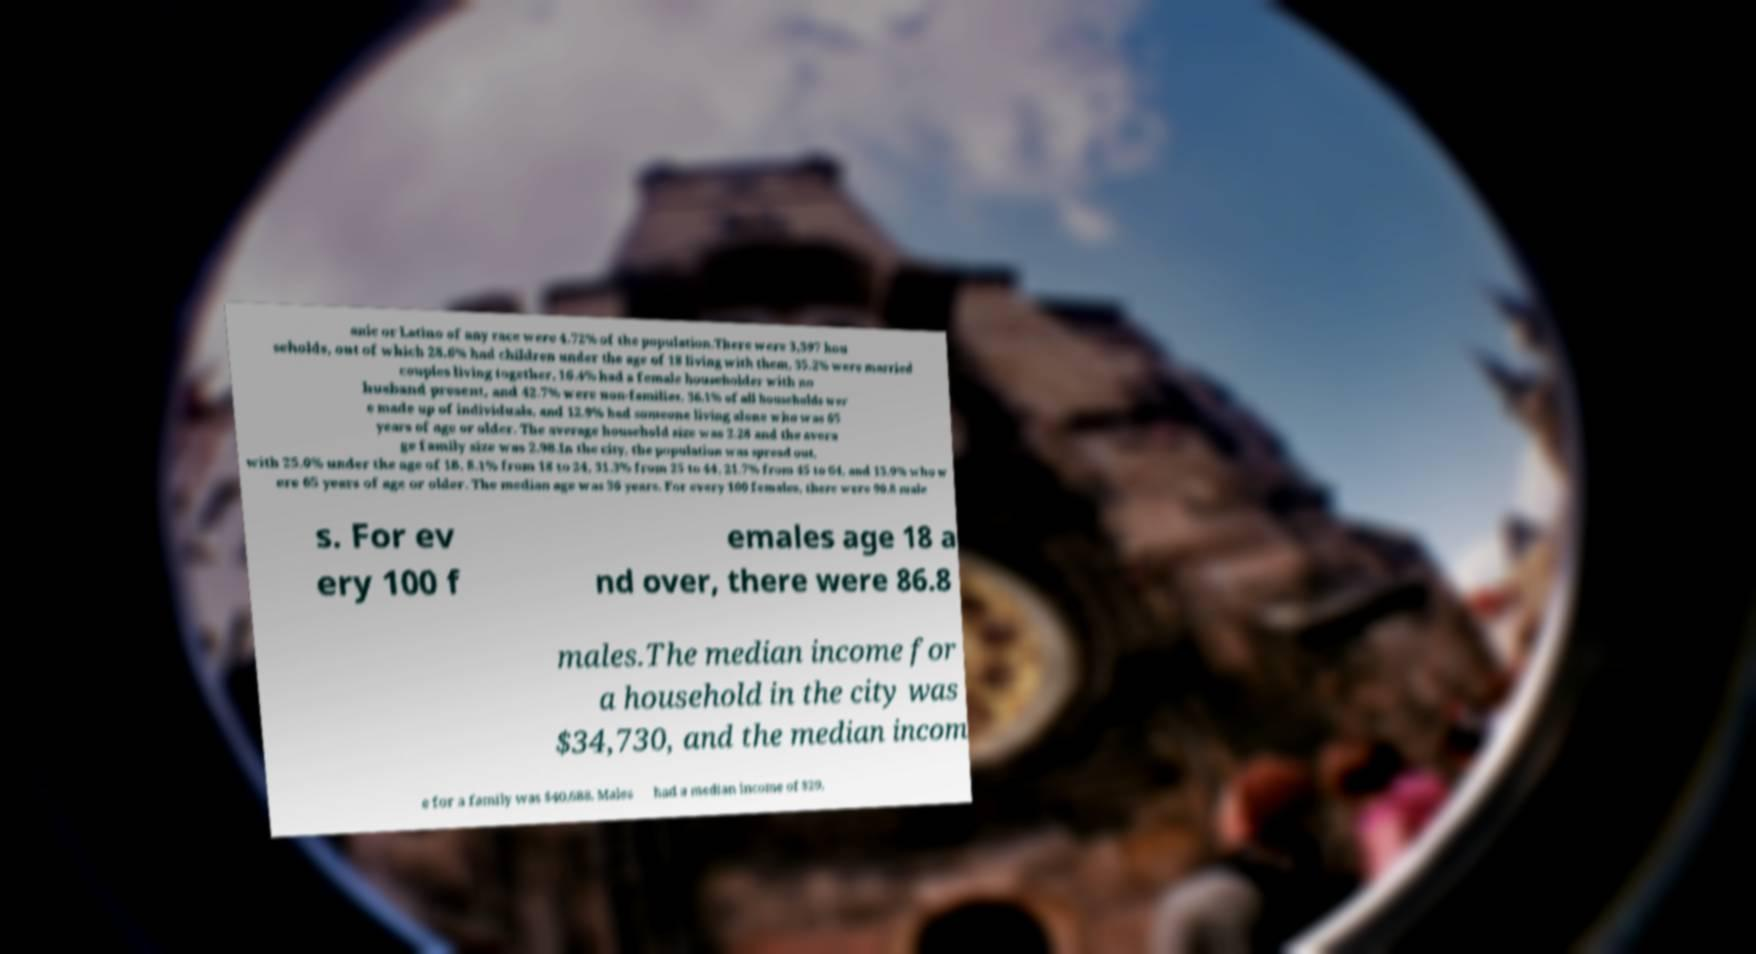Please read and relay the text visible in this image. What does it say? anic or Latino of any race were 4.72% of the population.There were 3,397 hou seholds, out of which 28.6% had children under the age of 18 living with them, 35.2% were married couples living together, 16.4% had a female householder with no husband present, and 42.7% were non-families. 36.1% of all households wer e made up of individuals, and 12.9% had someone living alone who was 65 years of age or older. The average household size was 2.28 and the avera ge family size was 2.98.In the city, the population was spread out, with 25.0% under the age of 18, 8.1% from 18 to 24, 31.3% from 25 to 44, 21.7% from 45 to 64, and 13.9% who w ere 65 years of age or older. The median age was 36 years. For every 100 females, there were 90.8 male s. For ev ery 100 f emales age 18 a nd over, there were 86.8 males.The median income for a household in the city was $34,730, and the median incom e for a family was $40,688. Males had a median income of $29, 